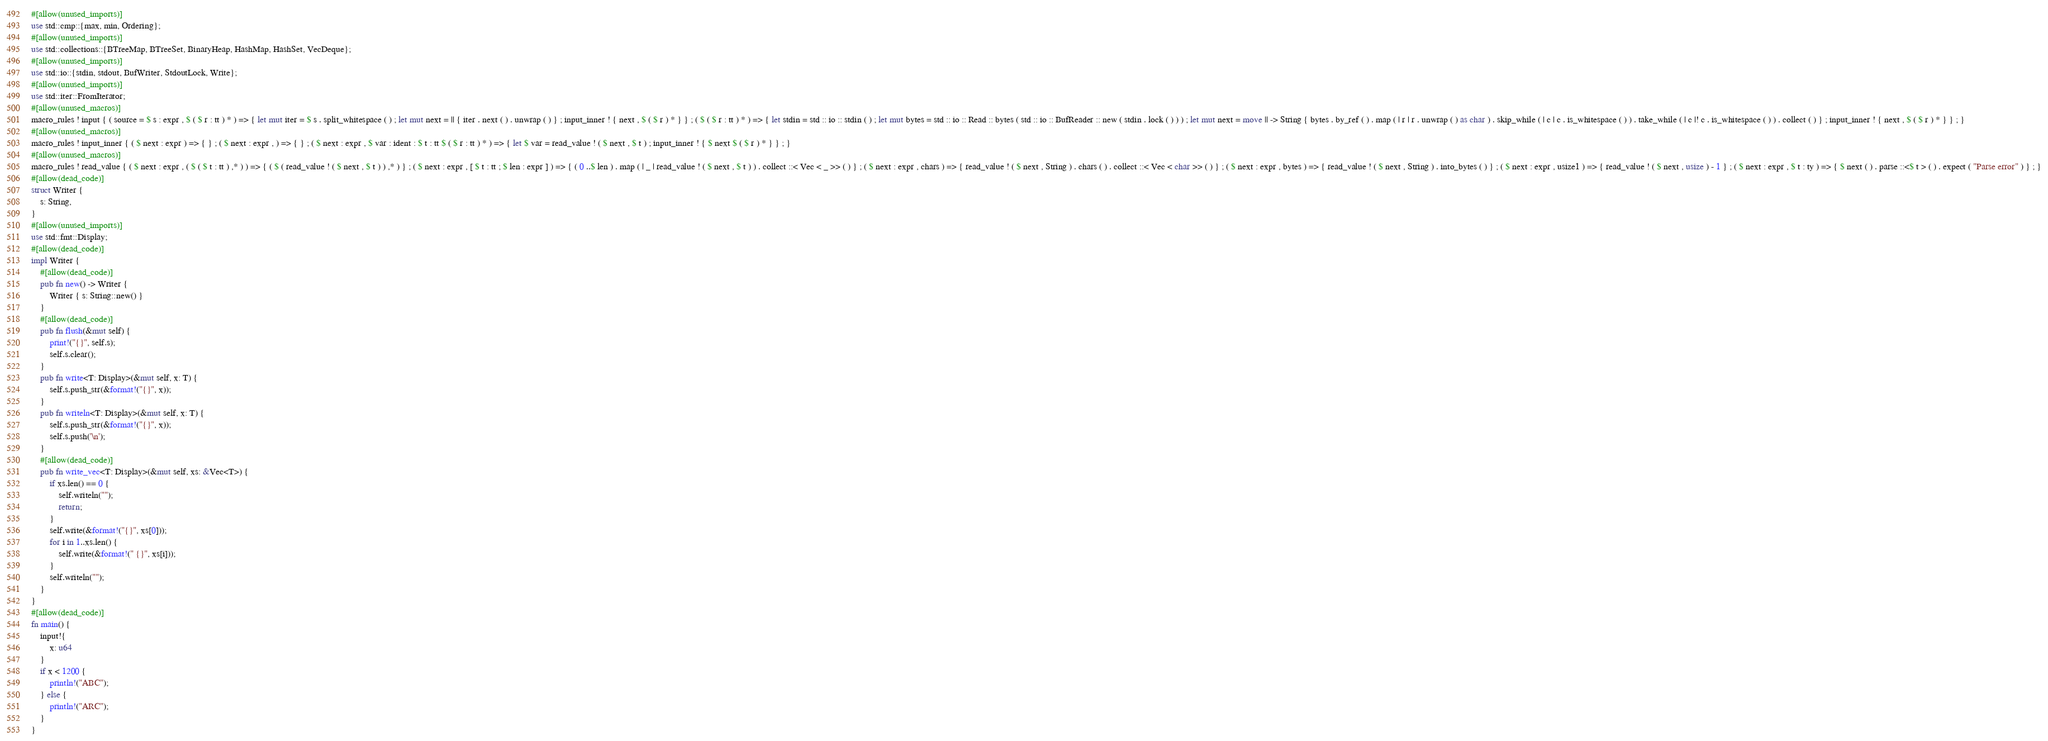Convert code to text. <code><loc_0><loc_0><loc_500><loc_500><_Rust_>#[allow(unused_imports)]
use std::cmp::{max, min, Ordering};
#[allow(unused_imports)]
use std::collections::{BTreeMap, BTreeSet, BinaryHeap, HashMap, HashSet, VecDeque};
#[allow(unused_imports)]
use std::io::{stdin, stdout, BufWriter, StdoutLock, Write};
#[allow(unused_imports)]
use std::iter::FromIterator;
#[allow(unused_macros)]
macro_rules ! input { ( source = $ s : expr , $ ( $ r : tt ) * ) => { let mut iter = $ s . split_whitespace ( ) ; let mut next = || { iter . next ( ) . unwrap ( ) } ; input_inner ! { next , $ ( $ r ) * } } ; ( $ ( $ r : tt ) * ) => { let stdin = std :: io :: stdin ( ) ; let mut bytes = std :: io :: Read :: bytes ( std :: io :: BufReader :: new ( stdin . lock ( ) ) ) ; let mut next = move || -> String { bytes . by_ref ( ) . map ( | r | r . unwrap ( ) as char ) . skip_while ( | c | c . is_whitespace ( ) ) . take_while ( | c |! c . is_whitespace ( ) ) . collect ( ) } ; input_inner ! { next , $ ( $ r ) * } } ; }
#[allow(unused_macros)]
macro_rules ! input_inner { ( $ next : expr ) => { } ; ( $ next : expr , ) => { } ; ( $ next : expr , $ var : ident : $ t : tt $ ( $ r : tt ) * ) => { let $ var = read_value ! ( $ next , $ t ) ; input_inner ! { $ next $ ( $ r ) * } } ; }
#[allow(unused_macros)]
macro_rules ! read_value { ( $ next : expr , ( $ ( $ t : tt ) ,* ) ) => { ( $ ( read_value ! ( $ next , $ t ) ) ,* ) } ; ( $ next : expr , [ $ t : tt ; $ len : expr ] ) => { ( 0 ..$ len ) . map ( | _ | read_value ! ( $ next , $ t ) ) . collect ::< Vec < _ >> ( ) } ; ( $ next : expr , chars ) => { read_value ! ( $ next , String ) . chars ( ) . collect ::< Vec < char >> ( ) } ; ( $ next : expr , bytes ) => { read_value ! ( $ next , String ) . into_bytes ( ) } ; ( $ next : expr , usize1 ) => { read_value ! ( $ next , usize ) - 1 } ; ( $ next : expr , $ t : ty ) => { $ next ( ) . parse ::<$ t > ( ) . expect ( "Parse error" ) } ; }
#[allow(dead_code)]
struct Writer {
    s: String,
}
#[allow(unused_imports)]
use std::fmt::Display;
#[allow(dead_code)]
impl Writer {
    #[allow(dead_code)]
    pub fn new() -> Writer {
        Writer { s: String::new() }
    }
    #[allow(dead_code)]
    pub fn flush(&mut self) {
        print!("{}", self.s);
        self.s.clear();
    }
    pub fn write<T: Display>(&mut self, x: T) {
        self.s.push_str(&format!("{}", x));
    }
    pub fn writeln<T: Display>(&mut self, x: T) {
        self.s.push_str(&format!("{}", x));
        self.s.push('\n');
    }
    #[allow(dead_code)]
    pub fn write_vec<T: Display>(&mut self, xs: &Vec<T>) {
        if xs.len() == 0 {
            self.writeln("");
            return;
        }
        self.write(&format!("{}", xs[0]));
        for i in 1..xs.len() {
            self.write(&format!(" {}", xs[i]));
        }
        self.writeln("");
    }
}
#[allow(dead_code)]
fn main() {
    input!{
        x: u64
    }
    if x < 1200 {
        println!("ABC");
    } else {
        println!("ARC");
    }
}</code> 